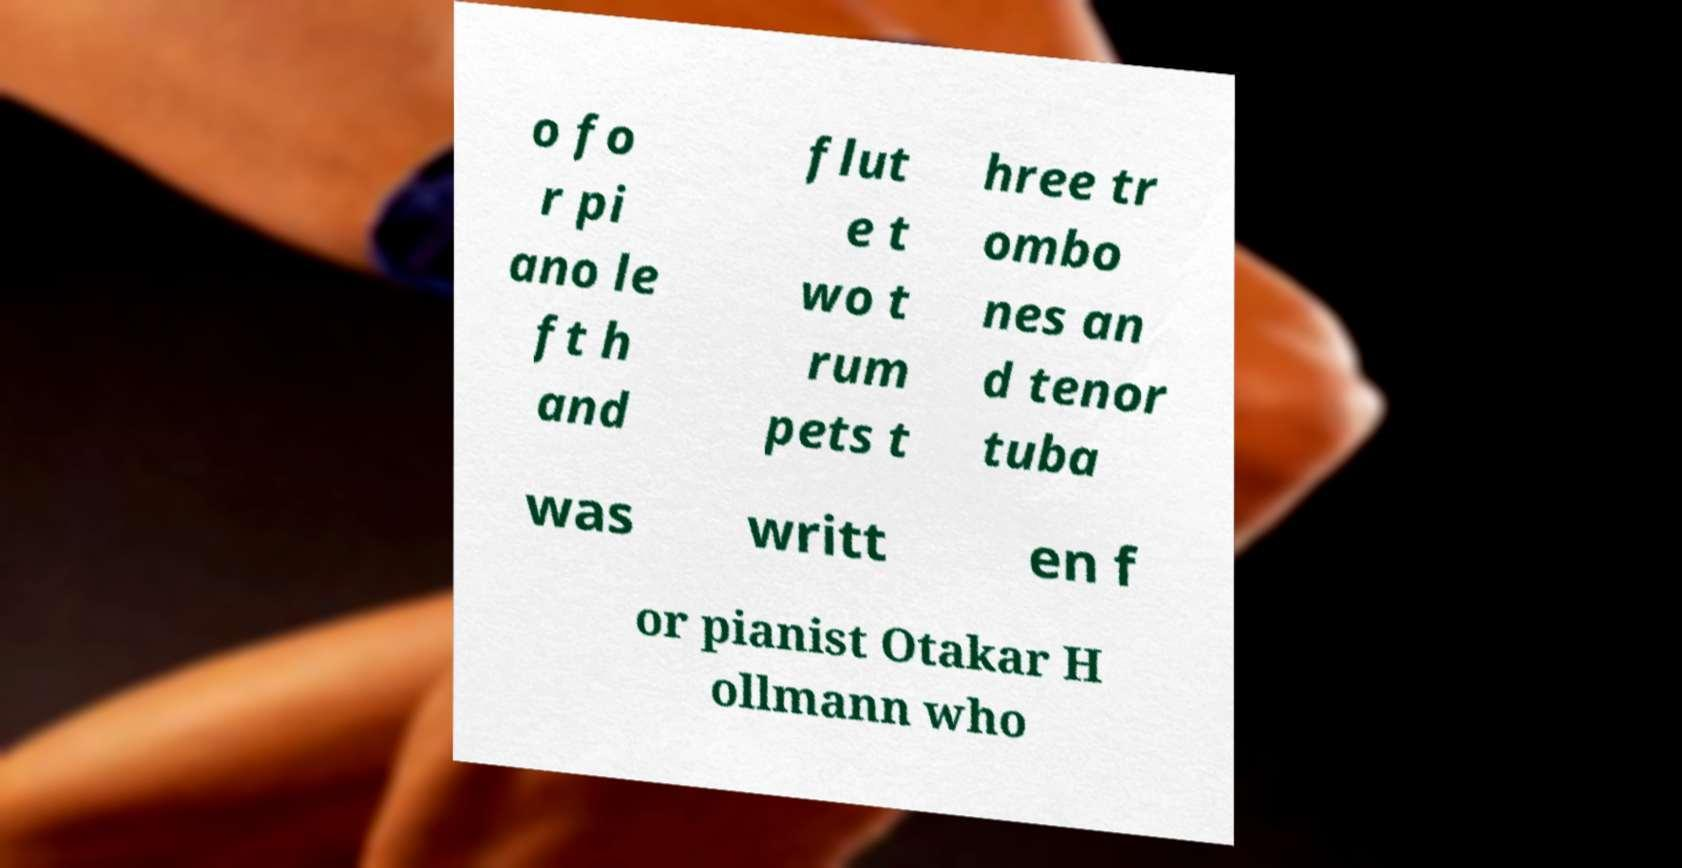For documentation purposes, I need the text within this image transcribed. Could you provide that? o fo r pi ano le ft h and flut e t wo t rum pets t hree tr ombo nes an d tenor tuba was writt en f or pianist Otakar H ollmann who 